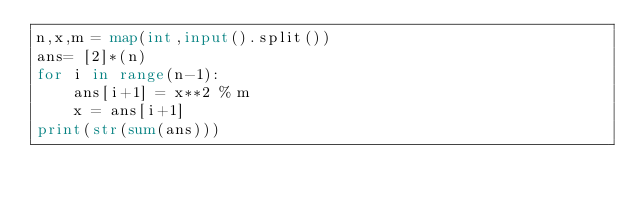<code> <loc_0><loc_0><loc_500><loc_500><_Python_>n,x,m = map(int,input().split())
ans= [2]*(n)
for i in range(n-1):
    ans[i+1] = x**2 % m
    x = ans[i+1]
print(str(sum(ans)))
</code> 